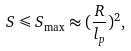Convert formula to latex. <formula><loc_0><loc_0><loc_500><loc_500>S \leqslant S _ { \max } \approx ( \frac { R } { l _ { p } } ) ^ { 2 } ,</formula> 